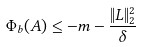Convert formula to latex. <formula><loc_0><loc_0><loc_500><loc_500>\Phi _ { b } ( A ) \leq - m - \frac { \| L \| _ { 2 } ^ { 2 } } { \delta }</formula> 